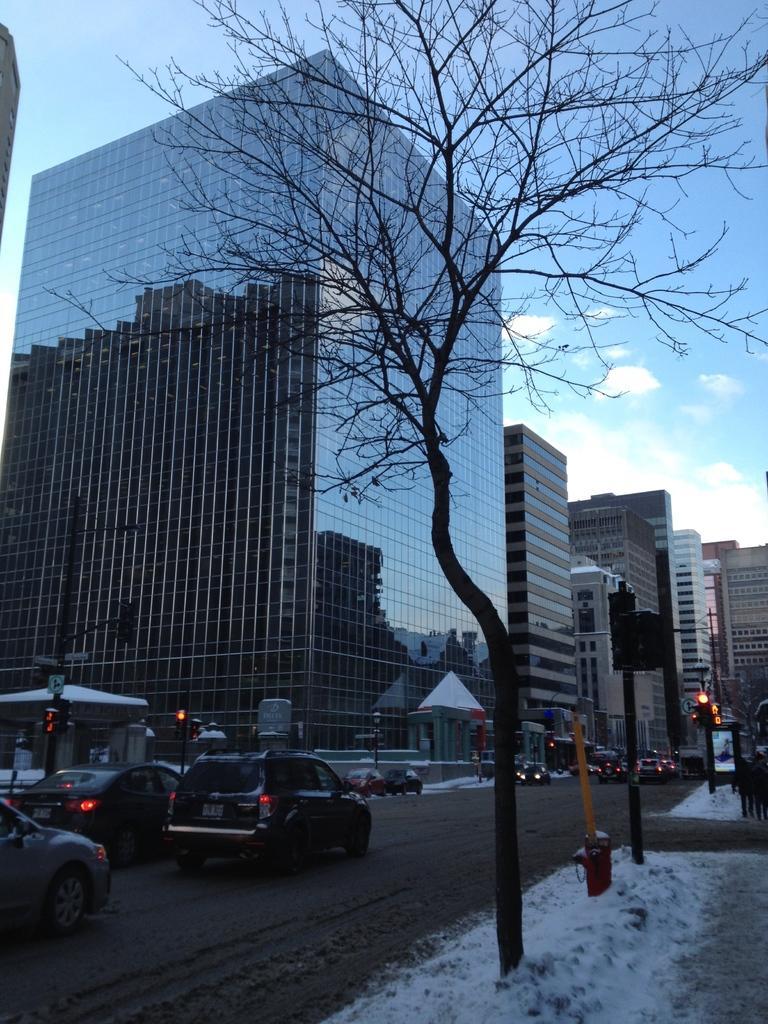In one or two sentences, can you explain what this image depicts? In this image I see the buildings, poles and I see the road on which there are vehicles and I see a tree over here and I see the white snow and I see the traffic signals. In the background I see the clear sky. 